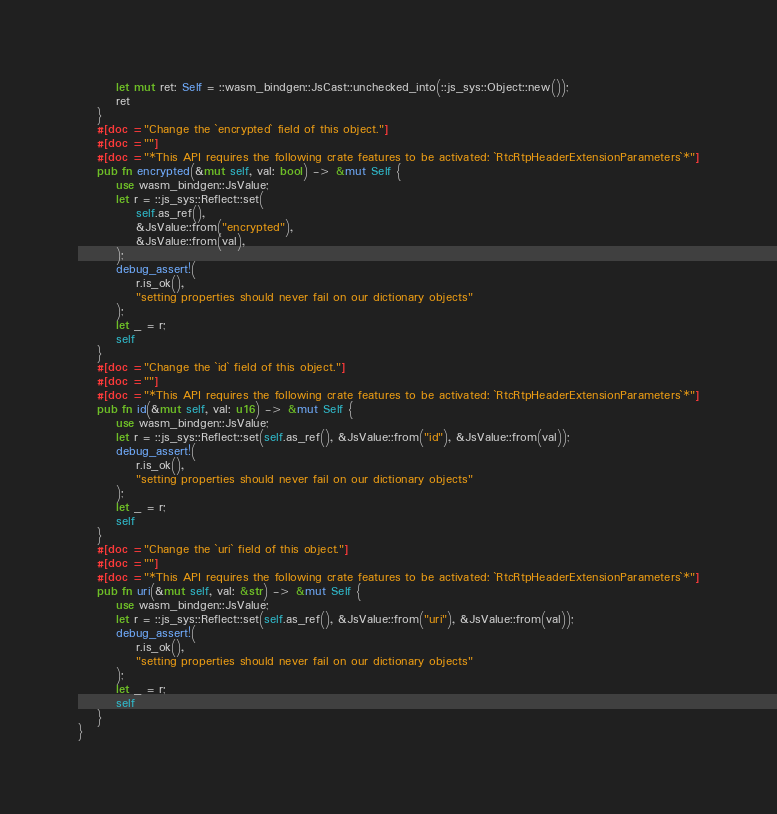<code> <loc_0><loc_0><loc_500><loc_500><_Rust_>        let mut ret: Self = ::wasm_bindgen::JsCast::unchecked_into(::js_sys::Object::new());
        ret
    }
    #[doc = "Change the `encrypted` field of this object."]
    #[doc = ""]
    #[doc = "*This API requires the following crate features to be activated: `RtcRtpHeaderExtensionParameters`*"]
    pub fn encrypted(&mut self, val: bool) -> &mut Self {
        use wasm_bindgen::JsValue;
        let r = ::js_sys::Reflect::set(
            self.as_ref(),
            &JsValue::from("encrypted"),
            &JsValue::from(val),
        );
        debug_assert!(
            r.is_ok(),
            "setting properties should never fail on our dictionary objects"
        );
        let _ = r;
        self
    }
    #[doc = "Change the `id` field of this object."]
    #[doc = ""]
    #[doc = "*This API requires the following crate features to be activated: `RtcRtpHeaderExtensionParameters`*"]
    pub fn id(&mut self, val: u16) -> &mut Self {
        use wasm_bindgen::JsValue;
        let r = ::js_sys::Reflect::set(self.as_ref(), &JsValue::from("id"), &JsValue::from(val));
        debug_assert!(
            r.is_ok(),
            "setting properties should never fail on our dictionary objects"
        );
        let _ = r;
        self
    }
    #[doc = "Change the `uri` field of this object."]
    #[doc = ""]
    #[doc = "*This API requires the following crate features to be activated: `RtcRtpHeaderExtensionParameters`*"]
    pub fn uri(&mut self, val: &str) -> &mut Self {
        use wasm_bindgen::JsValue;
        let r = ::js_sys::Reflect::set(self.as_ref(), &JsValue::from("uri"), &JsValue::from(val));
        debug_assert!(
            r.is_ok(),
            "setting properties should never fail on our dictionary objects"
        );
        let _ = r;
        self
    }
}
</code> 